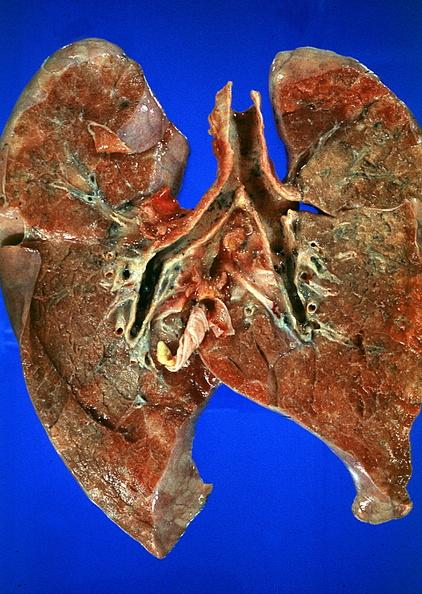does leukoplakia vocal cord show lung?
Answer the question using a single word or phrase. No 